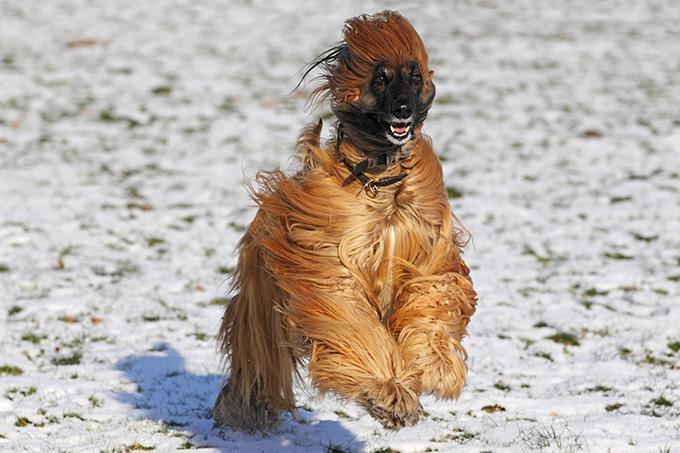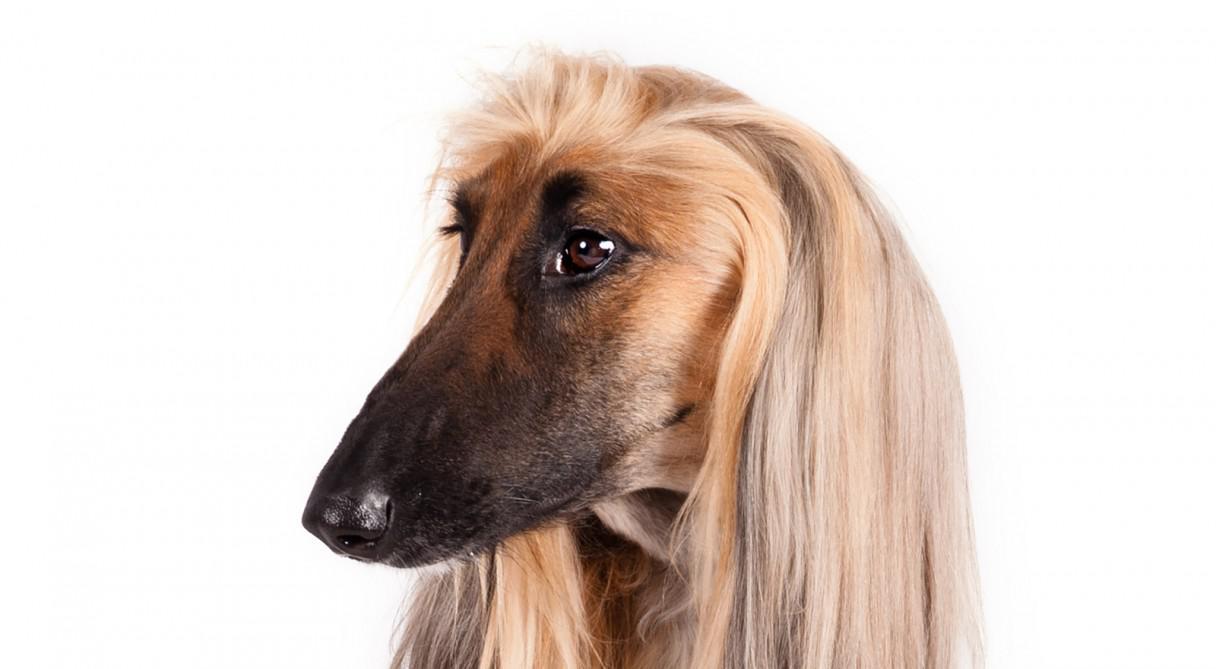The first image is the image on the left, the second image is the image on the right. For the images displayed, is the sentence "A hound poses in profile facing left, in the left image." factually correct? Answer yes or no. No. The first image is the image on the left, the second image is the image on the right. Examine the images to the left and right. Is the description "The dog in the image on the left is standing on all fours and facing left." accurate? Answer yes or no. No. 